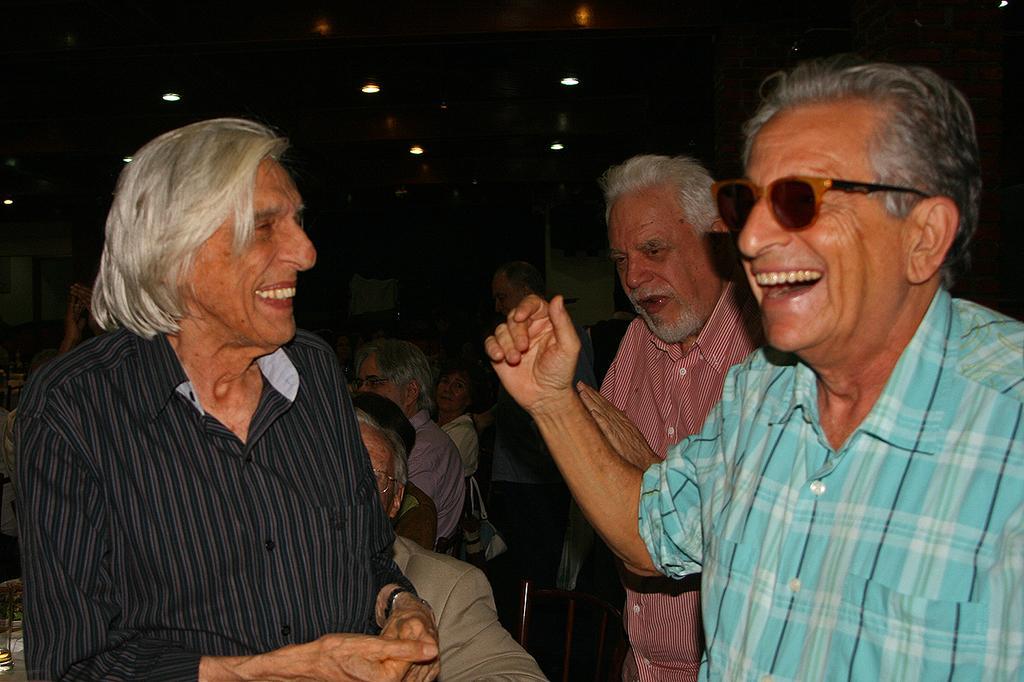Describe this image in one or two sentences. This picture shows a few people standing and few are seated on the chairs and we see man wore sunglasses on his face and and we see smile on his face and we see few lights on the roof. 